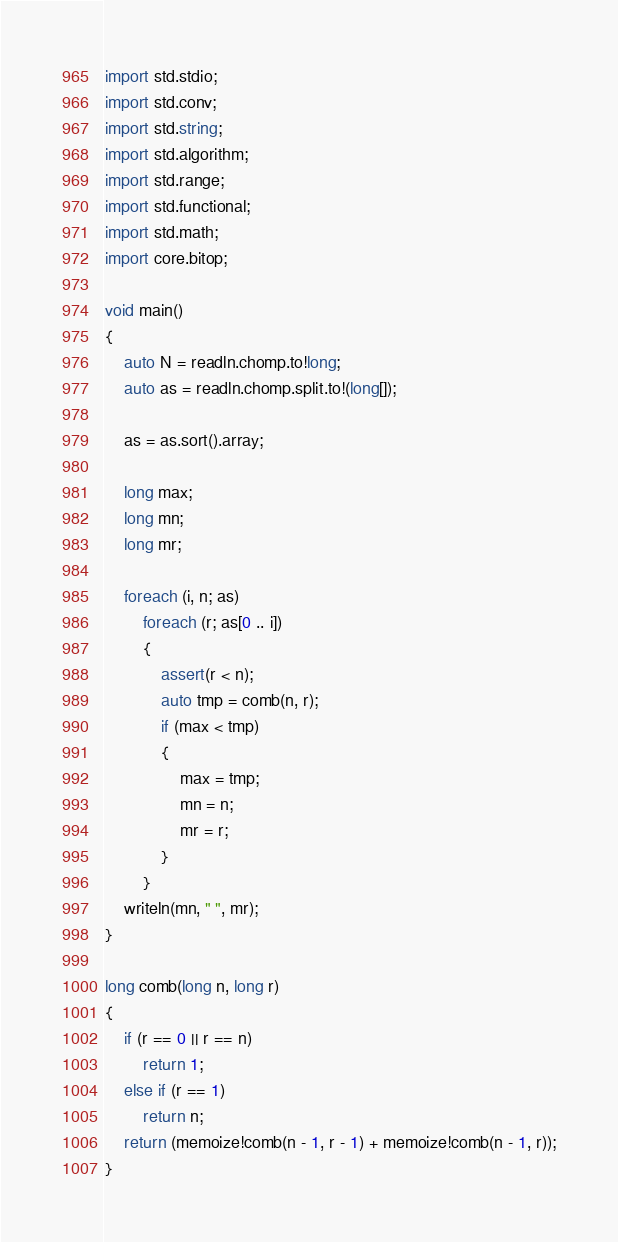Convert code to text. <code><loc_0><loc_0><loc_500><loc_500><_D_>import std.stdio;
import std.conv;
import std.string;
import std.algorithm;
import std.range;
import std.functional;
import std.math;
import core.bitop;

void main()
{
    auto N = readln.chomp.to!long;
    auto as = readln.chomp.split.to!(long[]);

    as = as.sort().array;

    long max;
    long mn;
    long mr;

    foreach (i, n; as)
        foreach (r; as[0 .. i])
        {
            assert(r < n);
            auto tmp = comb(n, r);
            if (max < tmp)
            {
                max = tmp;
                mn = n;
                mr = r;
            }
        }
    writeln(mn, " ", mr);
}

long comb(long n, long r)
{
    if (r == 0 || r == n)
        return 1;
    else if (r == 1)
        return n;
    return (memoize!comb(n - 1, r - 1) + memoize!comb(n - 1, r));
}
</code> 